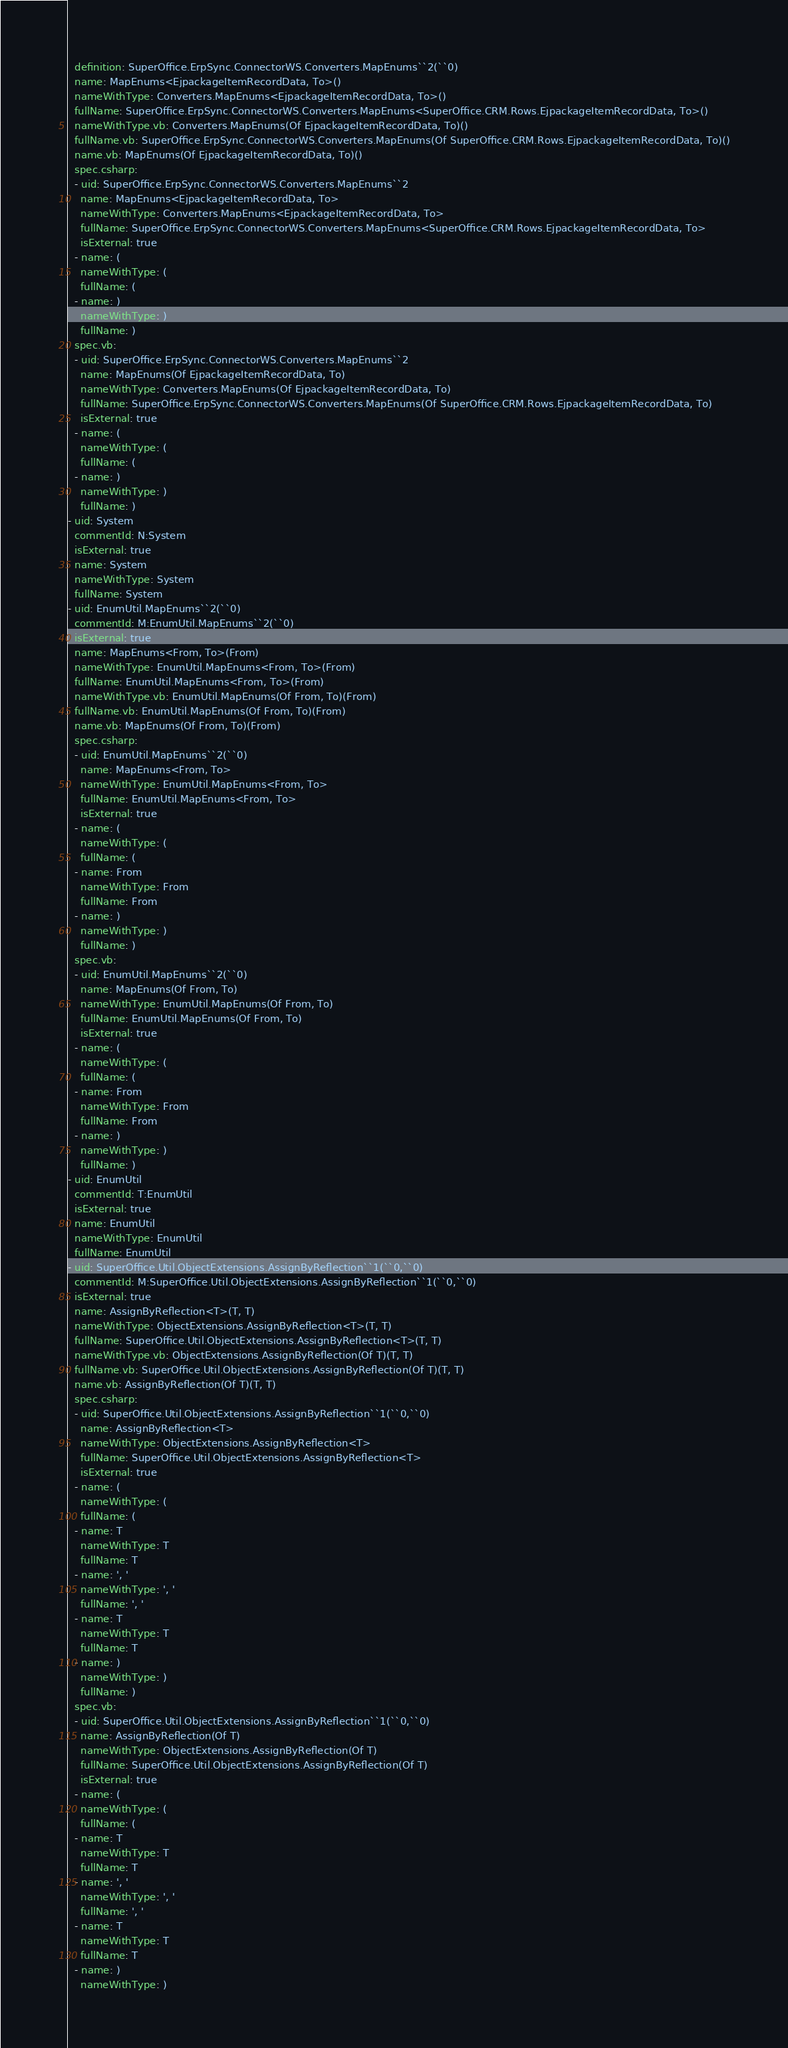<code> <loc_0><loc_0><loc_500><loc_500><_YAML_>  definition: SuperOffice.ErpSync.ConnectorWS.Converters.MapEnums``2(``0)
  name: MapEnums<EjpackageItemRecordData, To>()
  nameWithType: Converters.MapEnums<EjpackageItemRecordData, To>()
  fullName: SuperOffice.ErpSync.ConnectorWS.Converters.MapEnums<SuperOffice.CRM.Rows.EjpackageItemRecordData, To>()
  nameWithType.vb: Converters.MapEnums(Of EjpackageItemRecordData, To)()
  fullName.vb: SuperOffice.ErpSync.ConnectorWS.Converters.MapEnums(Of SuperOffice.CRM.Rows.EjpackageItemRecordData, To)()
  name.vb: MapEnums(Of EjpackageItemRecordData, To)()
  spec.csharp:
  - uid: SuperOffice.ErpSync.ConnectorWS.Converters.MapEnums``2
    name: MapEnums<EjpackageItemRecordData, To>
    nameWithType: Converters.MapEnums<EjpackageItemRecordData, To>
    fullName: SuperOffice.ErpSync.ConnectorWS.Converters.MapEnums<SuperOffice.CRM.Rows.EjpackageItemRecordData, To>
    isExternal: true
  - name: (
    nameWithType: (
    fullName: (
  - name: )
    nameWithType: )
    fullName: )
  spec.vb:
  - uid: SuperOffice.ErpSync.ConnectorWS.Converters.MapEnums``2
    name: MapEnums(Of EjpackageItemRecordData, To)
    nameWithType: Converters.MapEnums(Of EjpackageItemRecordData, To)
    fullName: SuperOffice.ErpSync.ConnectorWS.Converters.MapEnums(Of SuperOffice.CRM.Rows.EjpackageItemRecordData, To)
    isExternal: true
  - name: (
    nameWithType: (
    fullName: (
  - name: )
    nameWithType: )
    fullName: )
- uid: System
  commentId: N:System
  isExternal: true
  name: System
  nameWithType: System
  fullName: System
- uid: EnumUtil.MapEnums``2(``0)
  commentId: M:EnumUtil.MapEnums``2(``0)
  isExternal: true
  name: MapEnums<From, To>(From)
  nameWithType: EnumUtil.MapEnums<From, To>(From)
  fullName: EnumUtil.MapEnums<From, To>(From)
  nameWithType.vb: EnumUtil.MapEnums(Of From, To)(From)
  fullName.vb: EnumUtil.MapEnums(Of From, To)(From)
  name.vb: MapEnums(Of From, To)(From)
  spec.csharp:
  - uid: EnumUtil.MapEnums``2(``0)
    name: MapEnums<From, To>
    nameWithType: EnumUtil.MapEnums<From, To>
    fullName: EnumUtil.MapEnums<From, To>
    isExternal: true
  - name: (
    nameWithType: (
    fullName: (
  - name: From
    nameWithType: From
    fullName: From
  - name: )
    nameWithType: )
    fullName: )
  spec.vb:
  - uid: EnumUtil.MapEnums``2(``0)
    name: MapEnums(Of From, To)
    nameWithType: EnumUtil.MapEnums(Of From, To)
    fullName: EnumUtil.MapEnums(Of From, To)
    isExternal: true
  - name: (
    nameWithType: (
    fullName: (
  - name: From
    nameWithType: From
    fullName: From
  - name: )
    nameWithType: )
    fullName: )
- uid: EnumUtil
  commentId: T:EnumUtil
  isExternal: true
  name: EnumUtil
  nameWithType: EnumUtil
  fullName: EnumUtil
- uid: SuperOffice.Util.ObjectExtensions.AssignByReflection``1(``0,``0)
  commentId: M:SuperOffice.Util.ObjectExtensions.AssignByReflection``1(``0,``0)
  isExternal: true
  name: AssignByReflection<T>(T, T)
  nameWithType: ObjectExtensions.AssignByReflection<T>(T, T)
  fullName: SuperOffice.Util.ObjectExtensions.AssignByReflection<T>(T, T)
  nameWithType.vb: ObjectExtensions.AssignByReflection(Of T)(T, T)
  fullName.vb: SuperOffice.Util.ObjectExtensions.AssignByReflection(Of T)(T, T)
  name.vb: AssignByReflection(Of T)(T, T)
  spec.csharp:
  - uid: SuperOffice.Util.ObjectExtensions.AssignByReflection``1(``0,``0)
    name: AssignByReflection<T>
    nameWithType: ObjectExtensions.AssignByReflection<T>
    fullName: SuperOffice.Util.ObjectExtensions.AssignByReflection<T>
    isExternal: true
  - name: (
    nameWithType: (
    fullName: (
  - name: T
    nameWithType: T
    fullName: T
  - name: ', '
    nameWithType: ', '
    fullName: ', '
  - name: T
    nameWithType: T
    fullName: T
  - name: )
    nameWithType: )
    fullName: )
  spec.vb:
  - uid: SuperOffice.Util.ObjectExtensions.AssignByReflection``1(``0,``0)
    name: AssignByReflection(Of T)
    nameWithType: ObjectExtensions.AssignByReflection(Of T)
    fullName: SuperOffice.Util.ObjectExtensions.AssignByReflection(Of T)
    isExternal: true
  - name: (
    nameWithType: (
    fullName: (
  - name: T
    nameWithType: T
    fullName: T
  - name: ', '
    nameWithType: ', '
    fullName: ', '
  - name: T
    nameWithType: T
    fullName: T
  - name: )
    nameWithType: )</code> 